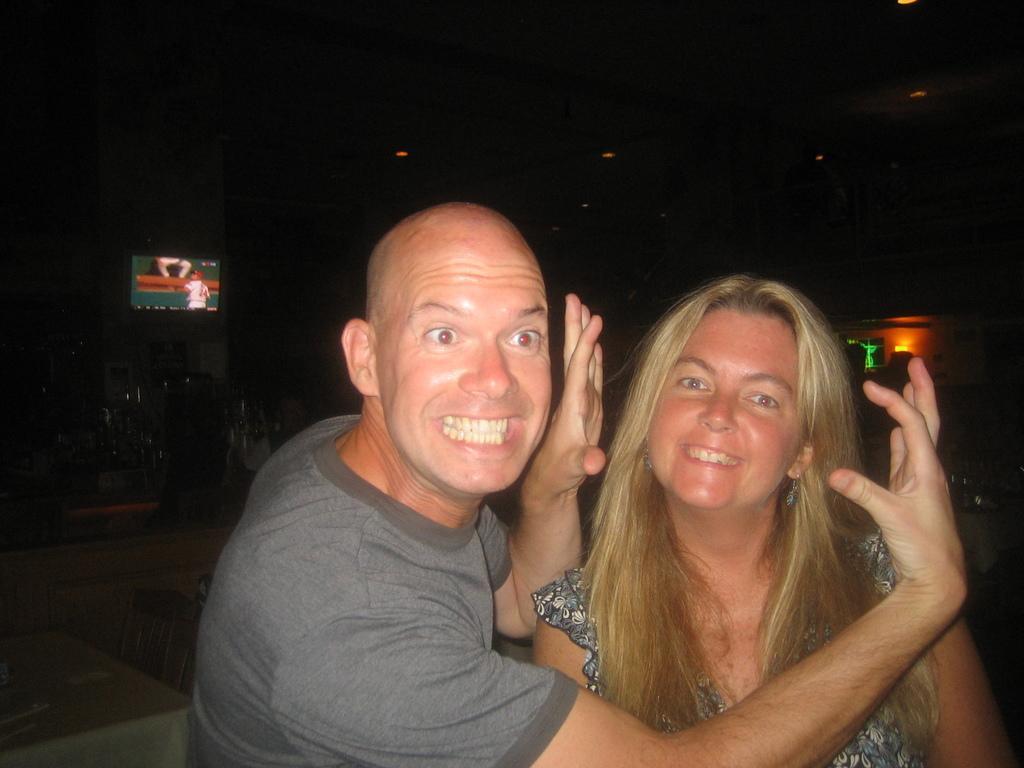Describe this image in one or two sentences. As we can see in the image there are two people standing in the front. In the background there is a television and a light. 